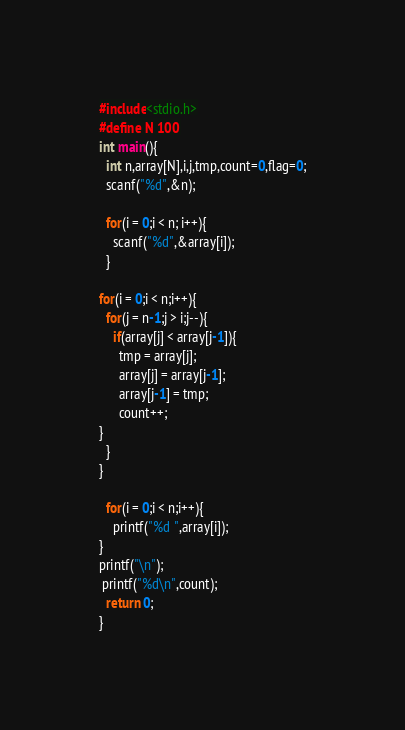Convert code to text. <code><loc_0><loc_0><loc_500><loc_500><_C_>#include<stdio.h>
#define N 100
int main(){
  int n,array[N],i,j,tmp,count=0,flag=0;
  scanf("%d",&n);

  for(i = 0;i < n; i++){
    scanf("%d",&array[i]);
  }

for(i = 0;i < n;i++){
  for(j = n-1;j > i;j--){
    if(array[j] < array[j-1]){
      tmp = array[j];
      array[j] = array[j-1]; 
      array[j-1] = tmp;
      count++;    
}
  }
}

  for(i = 0;i < n;i++){
    printf("%d ",array[i]);
}  
printf("\n");
 printf("%d\n",count);
  return 0;
}</code> 